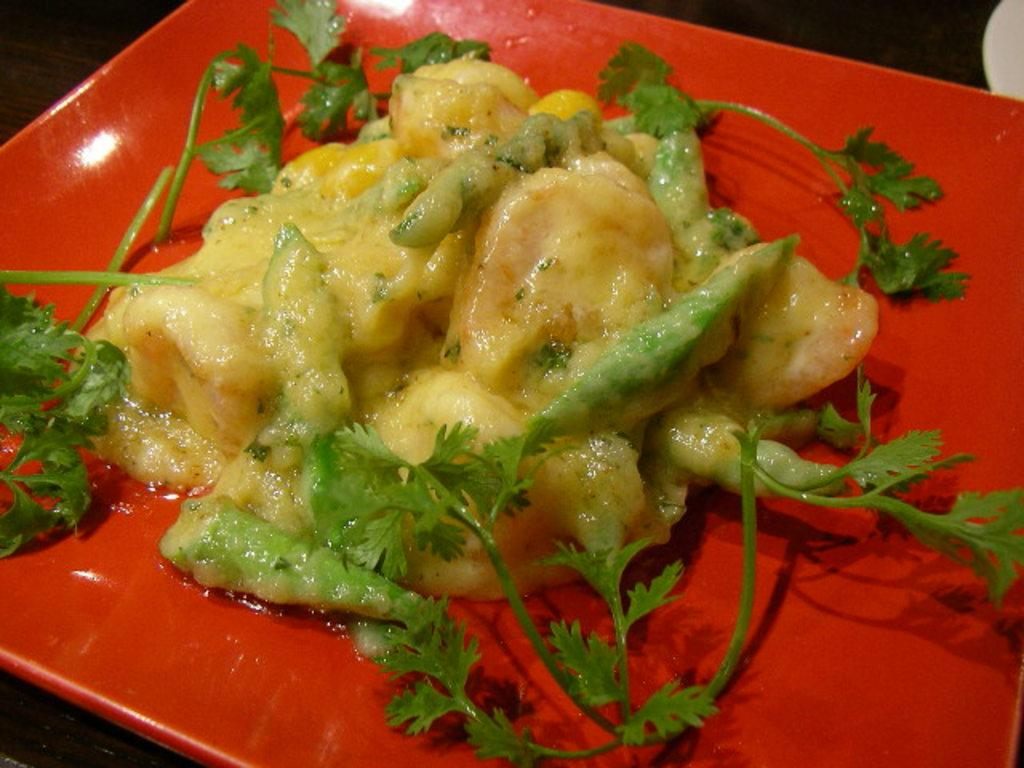What color is the plate that is visible in the image? There is a red color plate in the image. What is on the plate in the image? There is food on the plate in the image. What type of garnish is present on the plate? Mint leaves are present on the plate. What type of ball is visible on the plate in the image? There is no ball present on the plate in the image. What type of pump is used to prepare the food on the plate? There is no pump mentioned or visible in the image. 